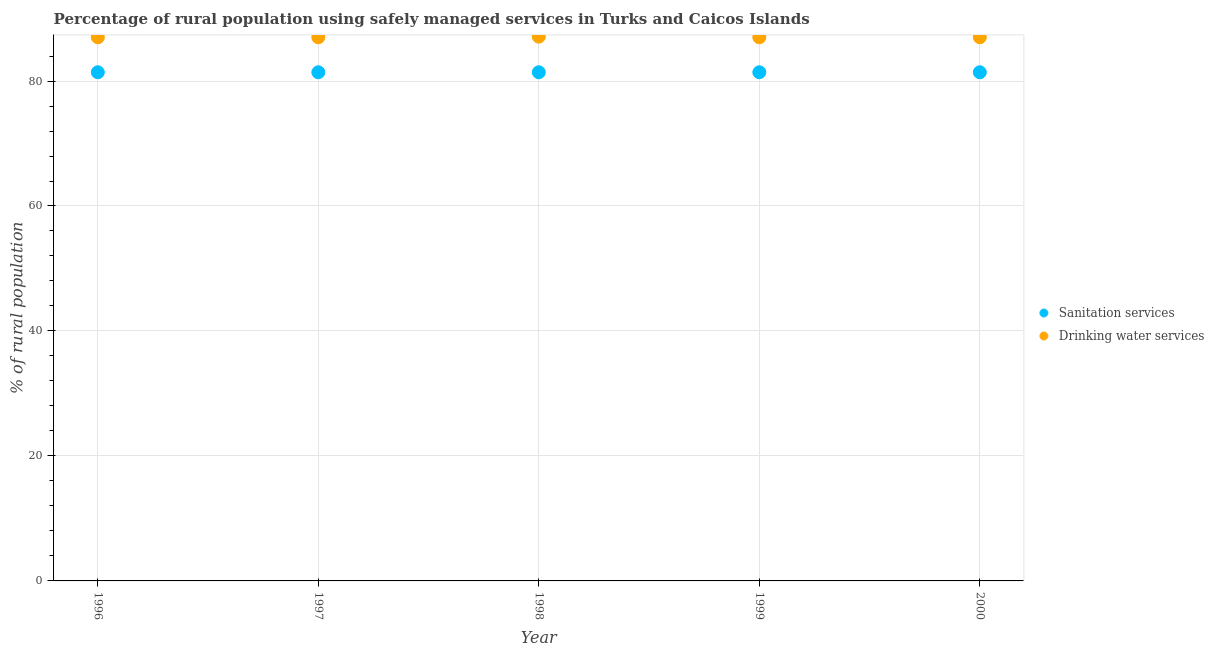How many different coloured dotlines are there?
Provide a succinct answer. 2. What is the percentage of rural population who used sanitation services in 1998?
Ensure brevity in your answer.  81.4. Across all years, what is the maximum percentage of rural population who used sanitation services?
Offer a terse response. 81.4. Across all years, what is the minimum percentage of rural population who used sanitation services?
Keep it short and to the point. 81.4. In which year was the percentage of rural population who used drinking water services maximum?
Your response must be concise. 1998. In which year was the percentage of rural population who used sanitation services minimum?
Keep it short and to the point. 1996. What is the total percentage of rural population who used sanitation services in the graph?
Provide a succinct answer. 407. What is the difference between the percentage of rural population who used sanitation services in 1996 and that in 1998?
Your response must be concise. 0. What is the difference between the percentage of rural population who used drinking water services in 1998 and the percentage of rural population who used sanitation services in 2000?
Give a very brief answer. 5.7. What is the average percentage of rural population who used drinking water services per year?
Offer a terse response. 87.02. In the year 1996, what is the difference between the percentage of rural population who used drinking water services and percentage of rural population who used sanitation services?
Ensure brevity in your answer.  5.6. In how many years, is the percentage of rural population who used drinking water services greater than 52 %?
Provide a succinct answer. 5. What is the ratio of the percentage of rural population who used sanitation services in 1996 to that in 1998?
Keep it short and to the point. 1. Is the percentage of rural population who used drinking water services in 1996 less than that in 1997?
Your response must be concise. No. Is the difference between the percentage of rural population who used drinking water services in 1996 and 1997 greater than the difference between the percentage of rural population who used sanitation services in 1996 and 1997?
Your answer should be very brief. No. What is the difference between the highest and the second highest percentage of rural population who used drinking water services?
Ensure brevity in your answer.  0.1. What is the difference between the highest and the lowest percentage of rural population who used drinking water services?
Make the answer very short. 0.1. Is the sum of the percentage of rural population who used drinking water services in 1997 and 1998 greater than the maximum percentage of rural population who used sanitation services across all years?
Make the answer very short. Yes. Is the percentage of rural population who used drinking water services strictly less than the percentage of rural population who used sanitation services over the years?
Give a very brief answer. No. How many dotlines are there?
Offer a terse response. 2. Does the graph contain grids?
Offer a very short reply. Yes. How many legend labels are there?
Ensure brevity in your answer.  2. How are the legend labels stacked?
Your answer should be compact. Vertical. What is the title of the graph?
Your response must be concise. Percentage of rural population using safely managed services in Turks and Caicos Islands. What is the label or title of the X-axis?
Your answer should be compact. Year. What is the label or title of the Y-axis?
Your answer should be compact. % of rural population. What is the % of rural population of Sanitation services in 1996?
Keep it short and to the point. 81.4. What is the % of rural population in Sanitation services in 1997?
Your response must be concise. 81.4. What is the % of rural population of Drinking water services in 1997?
Provide a succinct answer. 87. What is the % of rural population of Sanitation services in 1998?
Provide a succinct answer. 81.4. What is the % of rural population in Drinking water services in 1998?
Offer a very short reply. 87.1. What is the % of rural population of Sanitation services in 1999?
Offer a very short reply. 81.4. What is the % of rural population of Sanitation services in 2000?
Make the answer very short. 81.4. What is the % of rural population in Drinking water services in 2000?
Offer a terse response. 87. Across all years, what is the maximum % of rural population in Sanitation services?
Provide a succinct answer. 81.4. Across all years, what is the maximum % of rural population of Drinking water services?
Offer a terse response. 87.1. Across all years, what is the minimum % of rural population of Sanitation services?
Provide a succinct answer. 81.4. What is the total % of rural population of Sanitation services in the graph?
Offer a terse response. 407. What is the total % of rural population of Drinking water services in the graph?
Your answer should be compact. 435.1. What is the difference between the % of rural population of Sanitation services in 1996 and that in 1997?
Give a very brief answer. 0. What is the difference between the % of rural population of Drinking water services in 1996 and that in 1997?
Provide a short and direct response. 0. What is the difference between the % of rural population in Drinking water services in 1996 and that in 1999?
Provide a succinct answer. 0. What is the difference between the % of rural population of Drinking water services in 1996 and that in 2000?
Keep it short and to the point. 0. What is the difference between the % of rural population in Sanitation services in 1997 and that in 1998?
Your answer should be very brief. 0. What is the difference between the % of rural population of Drinking water services in 1997 and that in 1998?
Ensure brevity in your answer.  -0.1. What is the difference between the % of rural population in Sanitation services in 1997 and that in 1999?
Offer a very short reply. 0. What is the difference between the % of rural population of Drinking water services in 1997 and that in 1999?
Keep it short and to the point. 0. What is the difference between the % of rural population of Drinking water services in 1997 and that in 2000?
Your answer should be compact. 0. What is the difference between the % of rural population of Sanitation services in 1998 and that in 1999?
Keep it short and to the point. 0. What is the difference between the % of rural population of Drinking water services in 1998 and that in 1999?
Your answer should be very brief. 0.1. What is the difference between the % of rural population in Sanitation services in 1998 and that in 2000?
Offer a very short reply. 0. What is the difference between the % of rural population in Drinking water services in 1999 and that in 2000?
Make the answer very short. 0. What is the difference between the % of rural population in Sanitation services in 1996 and the % of rural population in Drinking water services in 1999?
Your answer should be very brief. -5.6. What is the difference between the % of rural population of Sanitation services in 1997 and the % of rural population of Drinking water services in 1998?
Provide a succinct answer. -5.7. What is the difference between the % of rural population of Sanitation services in 1997 and the % of rural population of Drinking water services in 1999?
Offer a terse response. -5.6. What is the difference between the % of rural population of Sanitation services in 1998 and the % of rural population of Drinking water services in 1999?
Provide a succinct answer. -5.6. What is the difference between the % of rural population in Sanitation services in 1998 and the % of rural population in Drinking water services in 2000?
Provide a short and direct response. -5.6. What is the average % of rural population of Sanitation services per year?
Make the answer very short. 81.4. What is the average % of rural population in Drinking water services per year?
Provide a short and direct response. 87.02. In the year 1996, what is the difference between the % of rural population of Sanitation services and % of rural population of Drinking water services?
Make the answer very short. -5.6. In the year 1998, what is the difference between the % of rural population of Sanitation services and % of rural population of Drinking water services?
Offer a very short reply. -5.7. In the year 1999, what is the difference between the % of rural population of Sanitation services and % of rural population of Drinking water services?
Offer a very short reply. -5.6. What is the ratio of the % of rural population in Sanitation services in 1996 to that in 1997?
Your response must be concise. 1. What is the ratio of the % of rural population of Drinking water services in 1996 to that in 1998?
Offer a very short reply. 1. What is the ratio of the % of rural population of Sanitation services in 1996 to that in 1999?
Make the answer very short. 1. What is the ratio of the % of rural population of Sanitation services in 1996 to that in 2000?
Your answer should be very brief. 1. What is the ratio of the % of rural population of Drinking water services in 1996 to that in 2000?
Offer a terse response. 1. What is the ratio of the % of rural population of Sanitation services in 1997 to that in 1998?
Offer a terse response. 1. What is the ratio of the % of rural population of Drinking water services in 1997 to that in 1998?
Give a very brief answer. 1. What is the ratio of the % of rural population of Sanitation services in 1997 to that in 1999?
Keep it short and to the point. 1. What is the ratio of the % of rural population of Drinking water services in 1997 to that in 1999?
Your answer should be very brief. 1. What is the ratio of the % of rural population of Sanitation services in 1998 to that in 1999?
Provide a succinct answer. 1. What is the ratio of the % of rural population in Drinking water services in 1998 to that in 1999?
Give a very brief answer. 1. What is the ratio of the % of rural population in Drinking water services in 1999 to that in 2000?
Keep it short and to the point. 1. What is the difference between the highest and the second highest % of rural population of Sanitation services?
Give a very brief answer. 0. What is the difference between the highest and the second highest % of rural population in Drinking water services?
Make the answer very short. 0.1. 